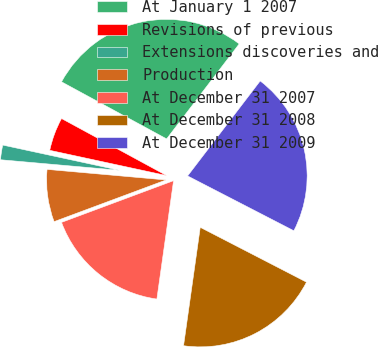Convert chart to OTSL. <chart><loc_0><loc_0><loc_500><loc_500><pie_chart><fcel>At January 1 2007<fcel>Revisions of previous<fcel>Extensions discoveries and<fcel>Production<fcel>At December 31 2007<fcel>At December 31 2008<fcel>At December 31 2009<nl><fcel>27.47%<fcel>4.53%<fcel>1.98%<fcel>7.08%<fcel>17.1%<fcel>19.65%<fcel>22.2%<nl></chart> 